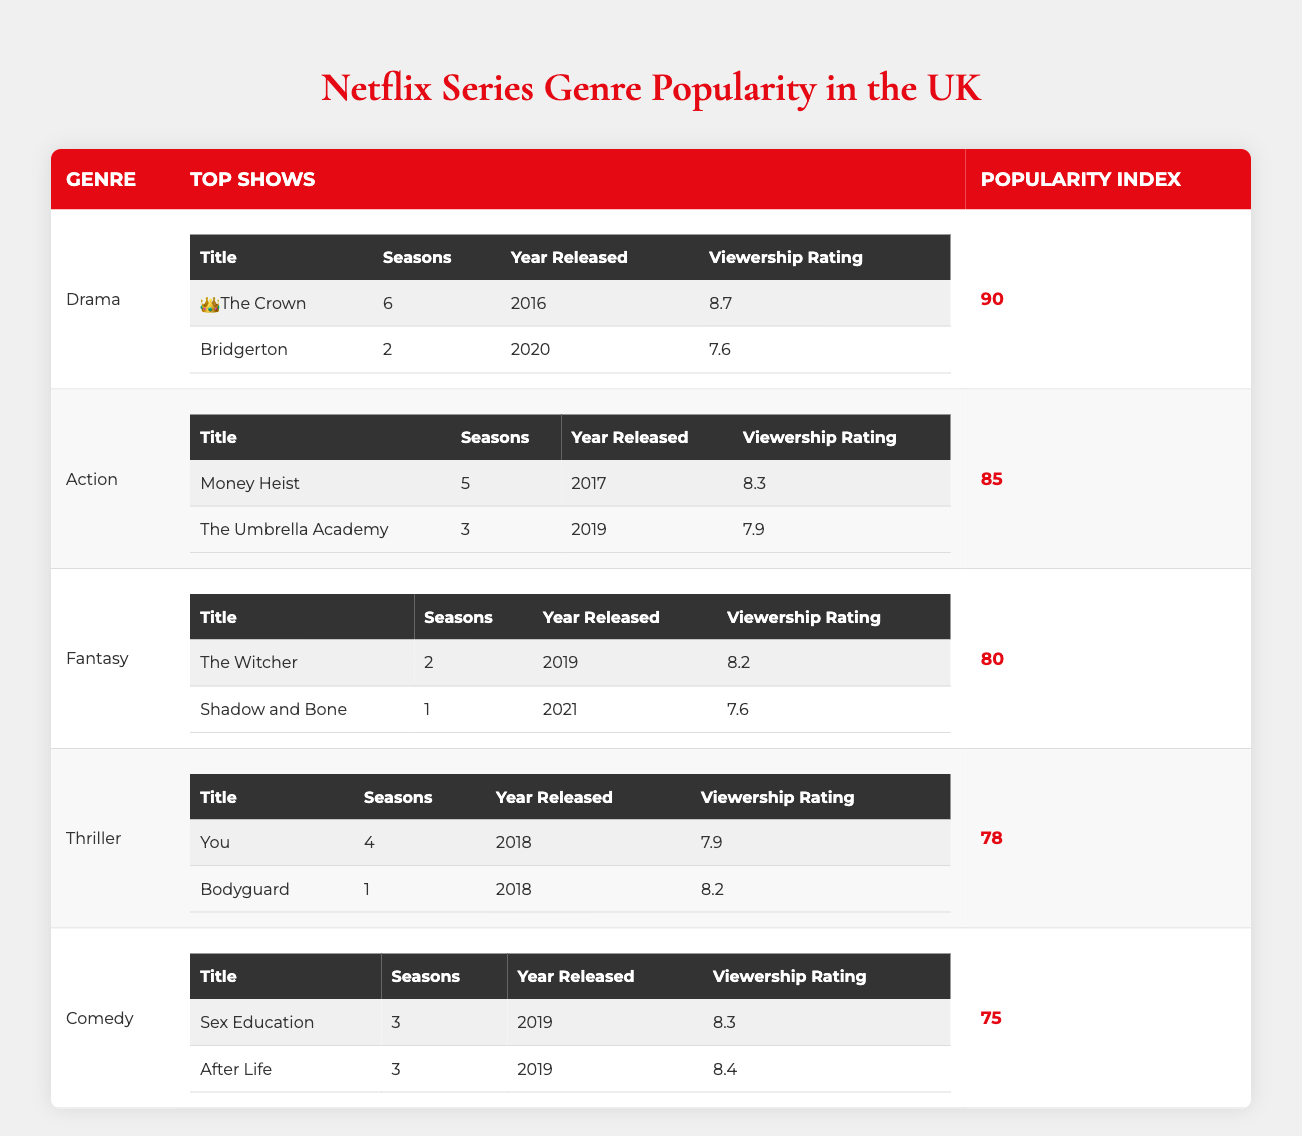What is the genre with the highest popularity index? By checking the popularity index for each genre in the table, Drama has the highest index of 90.
Answer: Drama Which show has the highest viewership rating among all the listed series? The viewership ratings are 8.7 for The Crown, 8.4 for After Life, 8.3 for Sex Education, 8.2 for The Witcher, 8.2 for Bodyguard, 8.3 for Money Heist, 7.9 for The Umbrella Academy, 7.9 for You, 7.6 for Bridgerton, and 7.6 for Shadow and Bone. The highest rating is 8.7 for The Crown.
Answer: The Crown What is the total number of seasons across all listed shows in the Comedy genre? For Comedy, the shows Sex Education and After Life have 3 and 3 seasons respectively, making a total of 3 + 3 = 6 seasons.
Answer: 6 Is it true that all the top shows in the Thriller genre were released in the same year? You was released in 2018 and Bodyguard was also released in 2018, so the statement is true; both shows in the Thriller genre were released in the same year.
Answer: Yes Which genre has fewer seasons when combining the top shows? The shows in Comedy have a total of 6 seasons, while Drama has 8, Action has 8, Fantasy has 3, and Thriller has 5. Comedy stands with 6 seasons, but Fantasy has only 3 seasons, which is the least.
Answer: Fantasy What is the average viewership rating of the top shows in Action? The viewership ratings for Money Heist and The Umbrella Academy are 8.3 and 7.9 respectively. To find the average, add the ratings (8.3 + 7.9 = 16.2) and divide by 2, giving an average of 16.2 / 2 = 8.1.
Answer: 8.1 How many genres have a popularity index above 80? Upon reviewing the table, Drama (90), Action (85), and Fantasy (80) have popularity indices above 80. Therefore, there are 3 genres with an index above 80.
Answer: 3 What is the release year range of all top shows listed? The shows were released from 2016 (The Crown) to 2021 (Shadow and Bone). This means the range is from 2016 to 2021.
Answer: 2016 to 2021 